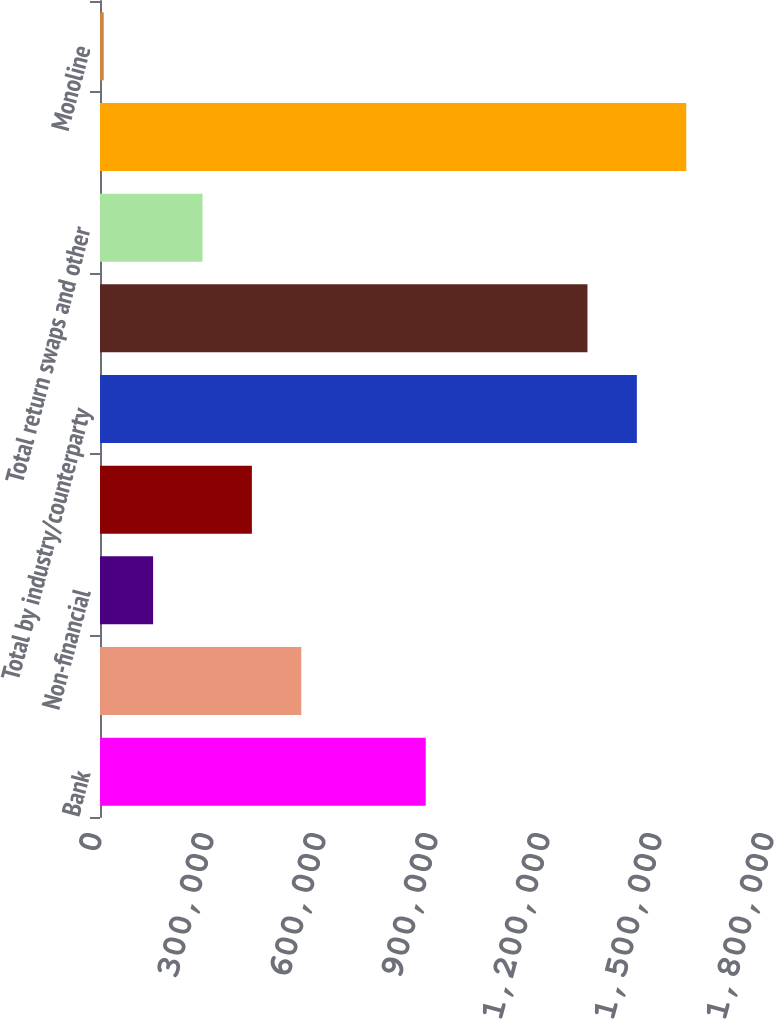Convert chart. <chart><loc_0><loc_0><loc_500><loc_500><bar_chart><fcel>Bank<fcel>Broker-dealer<fcel>Non-financial<fcel>Insurance and other financial<fcel>Total by industry/counterparty<fcel>Credit default swaps and<fcel>Total return swaps and other<fcel>Total by instrument<fcel>Monoline<nl><fcel>872523<fcel>539169<fcel>142272<fcel>406870<fcel>1.43802e+06<fcel>1.30572e+06<fcel>274571<fcel>1.57032e+06<fcel>9973<nl></chart> 